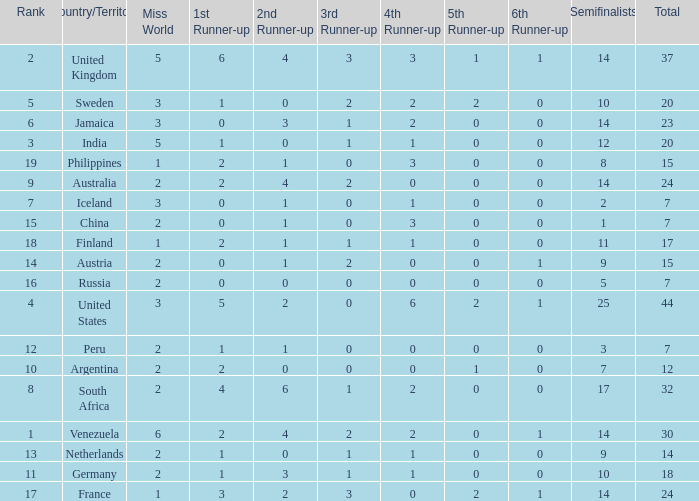What is Venezuela's total rank? 30.0. 